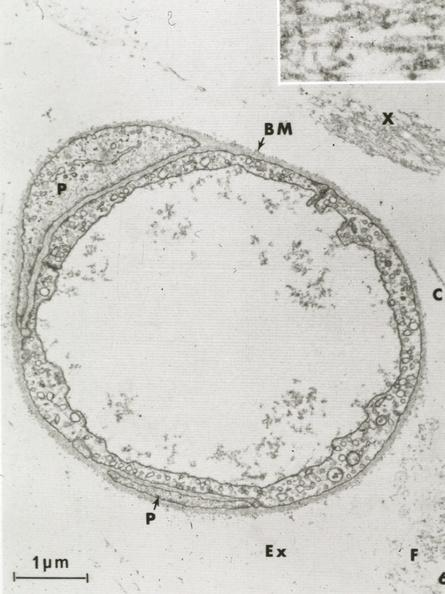what is present?
Answer the question using a single word or phrase. Cardiovascular 